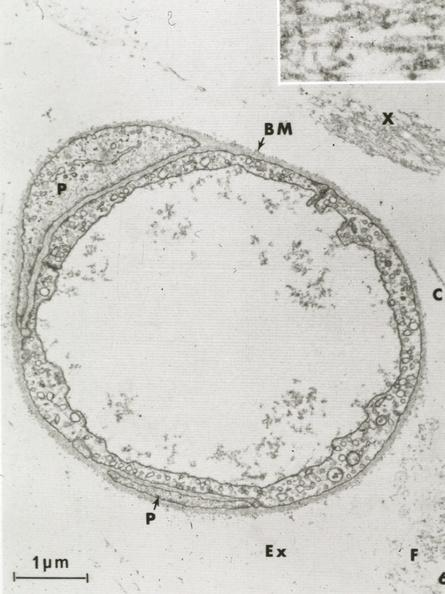what is present?
Answer the question using a single word or phrase. Cardiovascular 